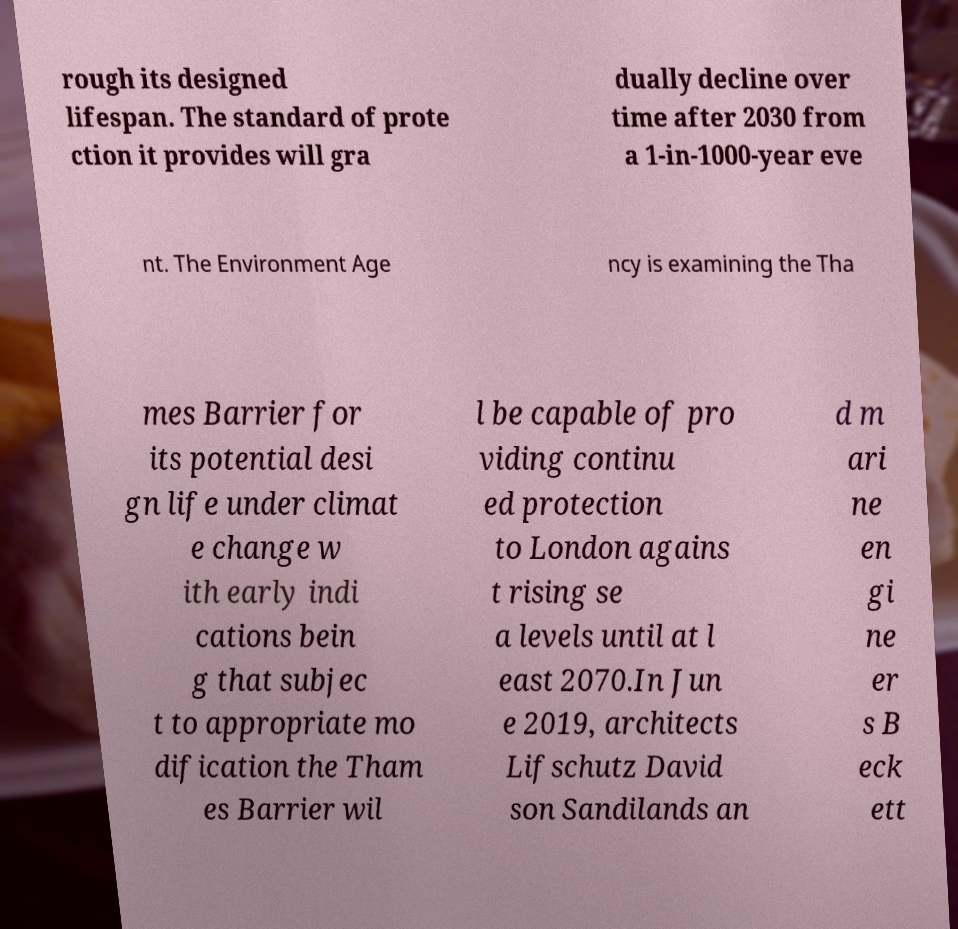Please read and relay the text visible in this image. What does it say? rough its designed lifespan. The standard of prote ction it provides will gra dually decline over time after 2030 from a 1-in-1000-year eve nt. The Environment Age ncy is examining the Tha mes Barrier for its potential desi gn life under climat e change w ith early indi cations bein g that subjec t to appropriate mo dification the Tham es Barrier wil l be capable of pro viding continu ed protection to London agains t rising se a levels until at l east 2070.In Jun e 2019, architects Lifschutz David son Sandilands an d m ari ne en gi ne er s B eck ett 